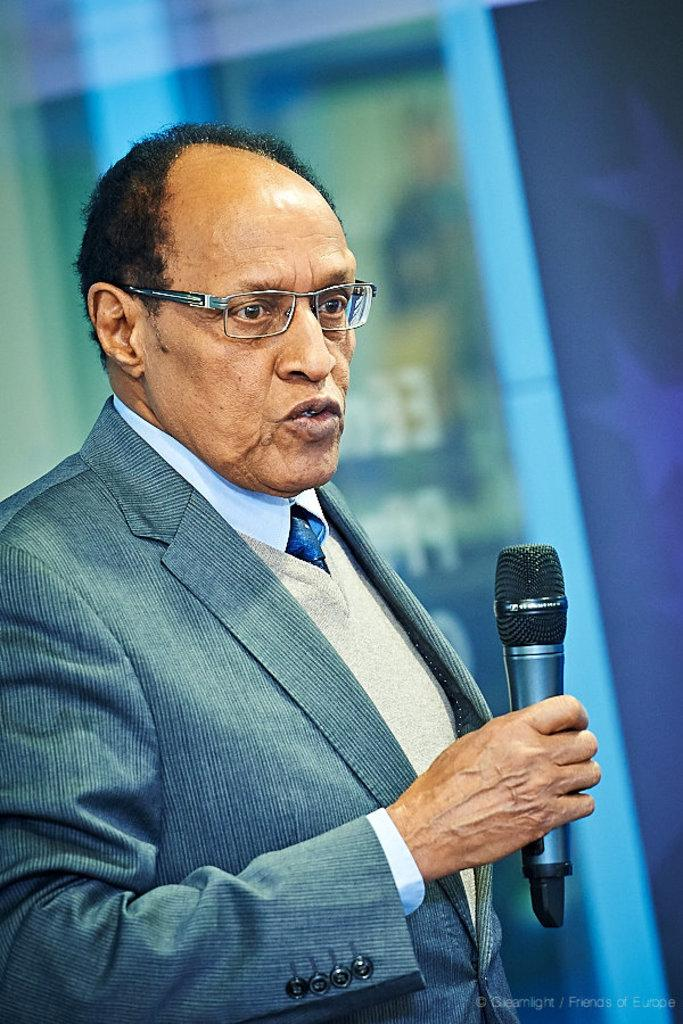Who is the main subject in the image? There is an old man in the image. What is the old man doing in the image? The old man is standing and speaking into a microphone. Can you describe the microphone in the image? The microphone is black in color and is being held by the old man. What can be seen in the background of the image? There is a blue color wall in the background of the image. Where is the rabbit hiding in the image? There is no rabbit present in the image. What type of selection process is being conducted in the image? There is no selection process depicted in the image; it features an old man holding a microphone. 